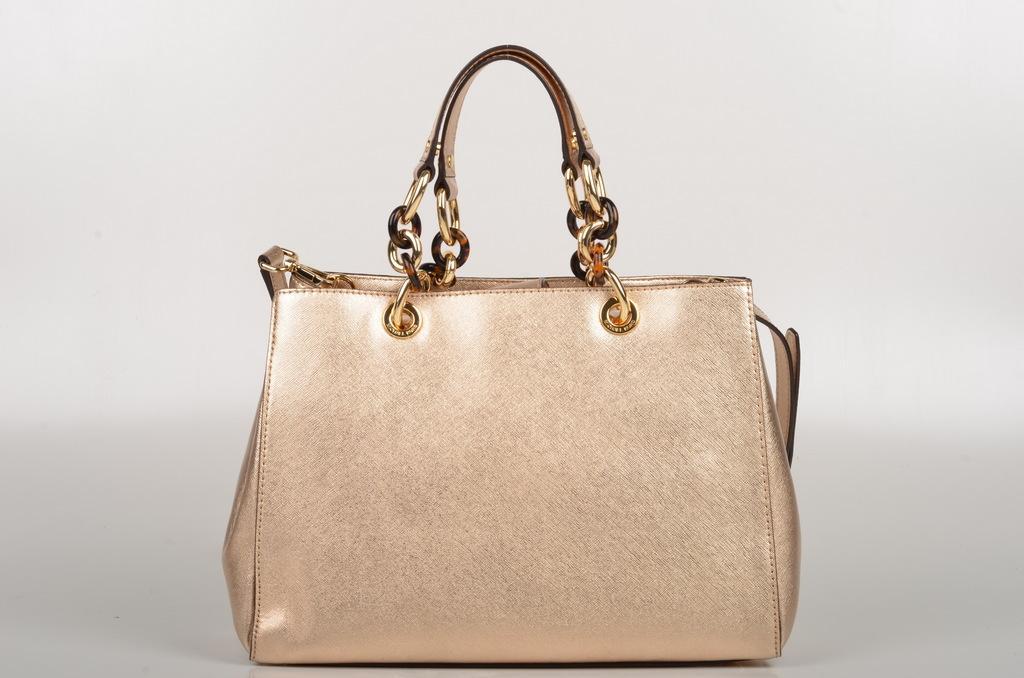How would you summarize this image in a sentence or two? In this image i can see a bag and a handle with a belt. 